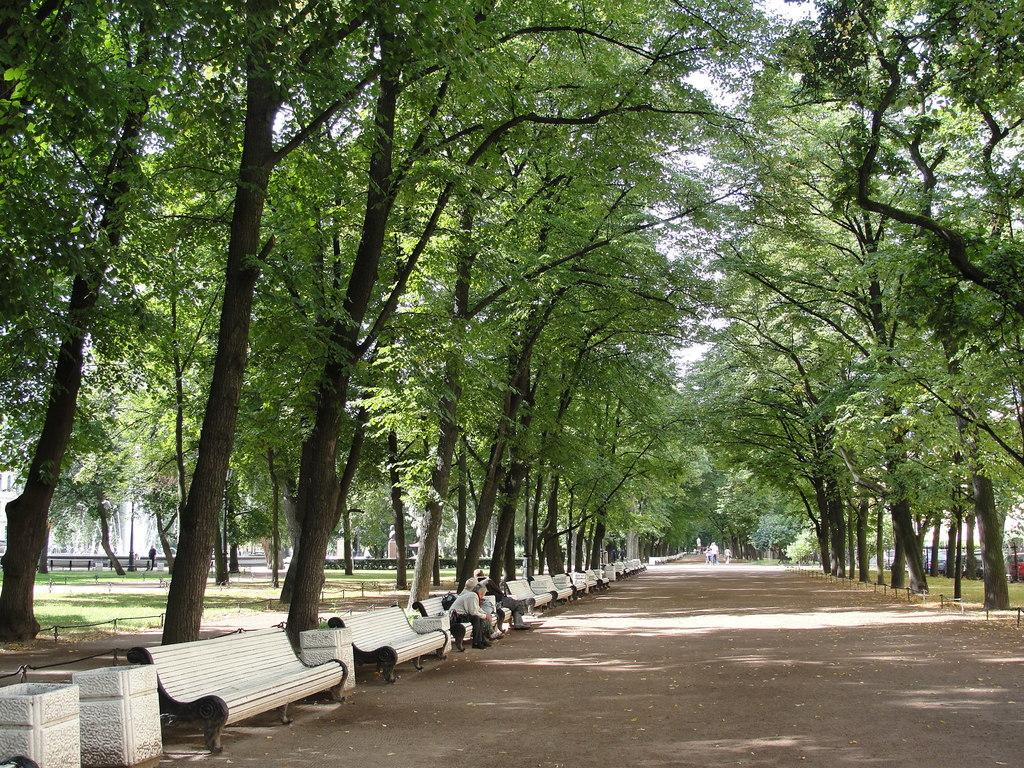What type of seating is present in the image? There are benches in the image. What colors are the benches? The benches are in white and black color. How many people are sitting on a bench? Two people are sitting on a bench. What can be seen on both sides of the image? There are trees on both sides of the image. What color is the sky in the image? The sky is in white color. What type of tray is being used by the people sitting on the bench? There is no tray present in the image; the people are simply sitting on the bench. 